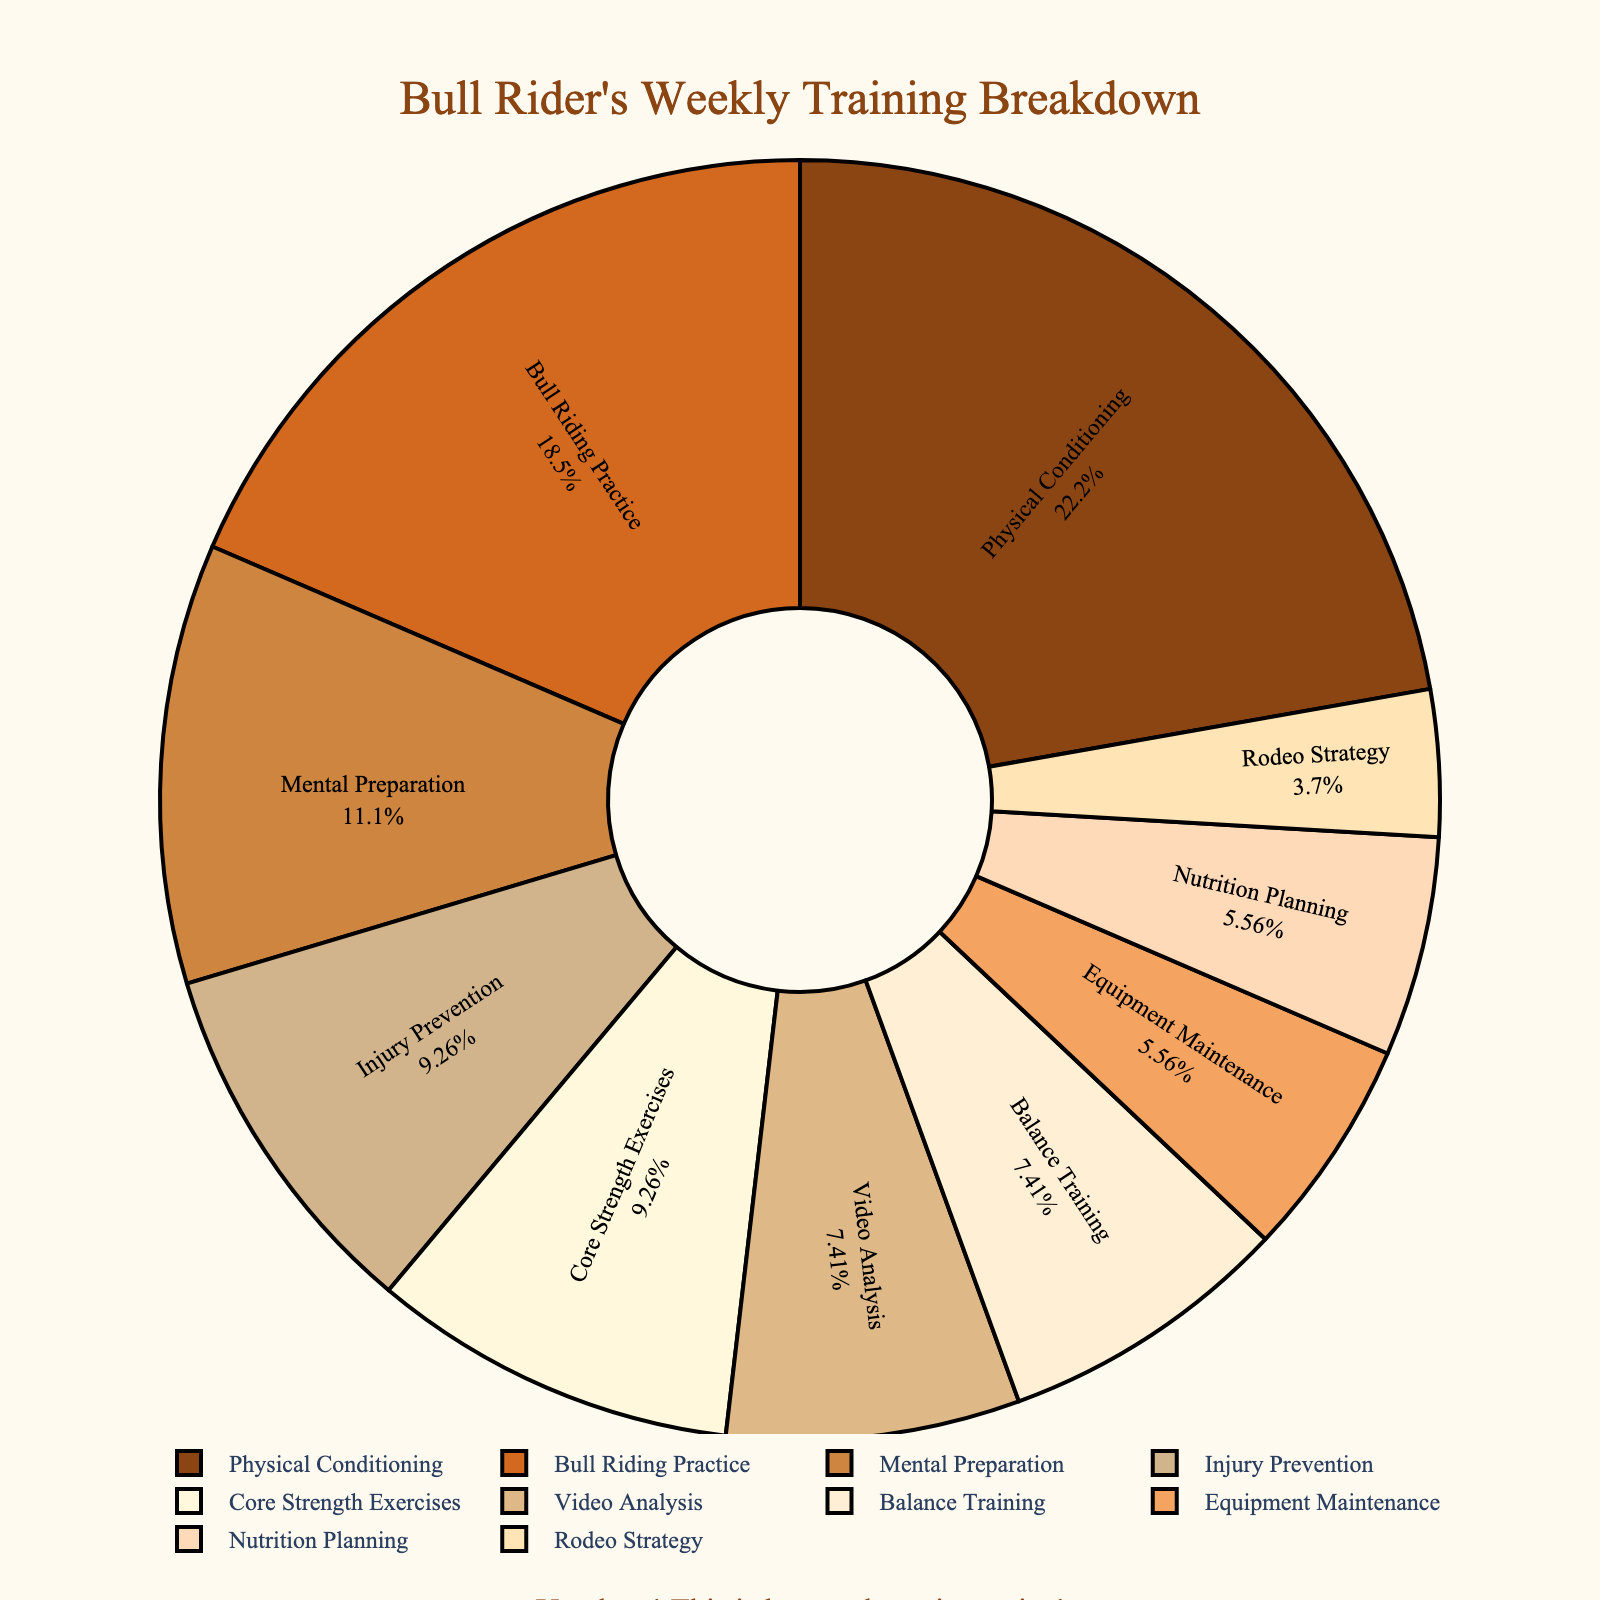What activity takes up the largest portion of the training time? The figure shows that "Physical Conditioning" has the largest slice of the pie chart, indicating it consumes the most hours each week.
Answer: Physical Conditioning How many hours per week are spent on activities related to physical health (Physical Conditioning, Injury Prevention, and Core Strength Exercises)? Add the hours for Physical Conditioning (12), Injury Prevention (5), and Core Strength Exercises (5). 12 + 5 + 5 = 22
Answer: 22 Which activities take up equal hours in the training plan? From the chart, we observe that "Nutrition Planning" and "Equipment Maintenance" both consume 3 hours per week.
Answer: Nutrition Planning, Equipment Maintenance Is more time dedicated to Mental Preparation or Video Analysis? The pie chart indicates that "Mental Preparation" takes up a larger portion than "Video Analysis."
Answer: Mental Preparation What percentage of the total training time is allocated to Bull Riding Practice? Bull Riding Practice accounts for 10 hours out of the total 54 hours. The percentage is (10/54) * 100 = 18.52%.
Answer: 18.52% How does the time spent on Balance Training compare to Video Analysis? Both Balance Training and Video Analysis are allocated 4 hours each in the training plan, so they are equal.
Answer: Equal Is the time spent on Equipment Maintenance more or less than on Rodeo Strategy? The chart shows that Equipment Maintenance takes up 3 hours, while Rodeo Strategy takes 2 hours, so Equipment Maintenance is greater.
Answer: Equipment Maintenance Calculate the combined percentage of time devoted to Injury Prevention and Core Strength Exercises. Injury Prevention is 5 hours and Core Strength Exercises are 5 hours. Combined, they are (5+5)/54 * 100 = 18.52%.
Answer: 18.52% Which activity segment is represented by a color closest to gold? By observing the colors in the chart, "Nutrition Planning" is assigned a light tan color that is close to gold.
Answer: Nutrition Planning Which activity is second in the amount of time allocation after Physical Conditioning? The second largest slice of the pie chart, following "Physical Conditioning," is "Bull Riding Practice" with 10 hours.
Answer: Bull Riding Practice 